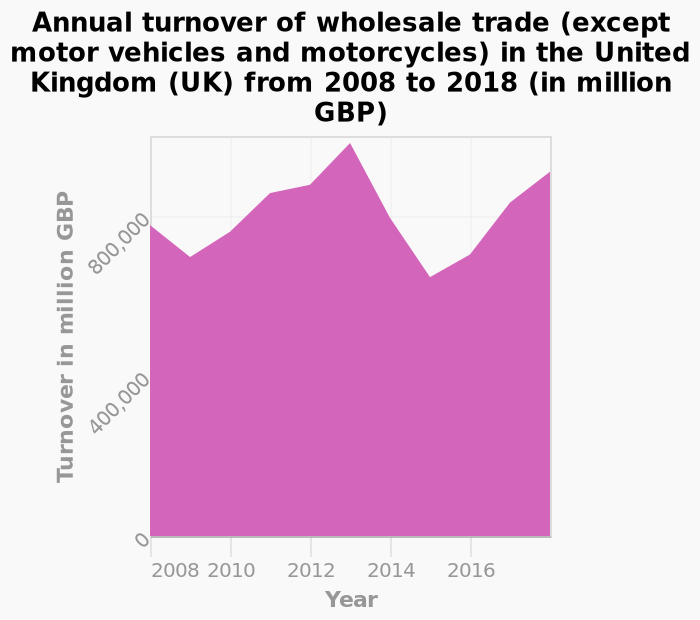<image>
Did the trade recover after 2015? Yes, the trade rose again quickly, going back to what they had lost. What happened to trade from 2013 to 2015? Trade dramatically slumped from 2013 to 2015, losing 400,000. What year had the highest turnover in wholesale trade? The highest turnover in wholesale trade was in 2013. Which industry does the graph focus on? The graph focuses on the wholesale trade industry, excluding motor vehicles and motorcycles, in the United Kingdom (UK). 